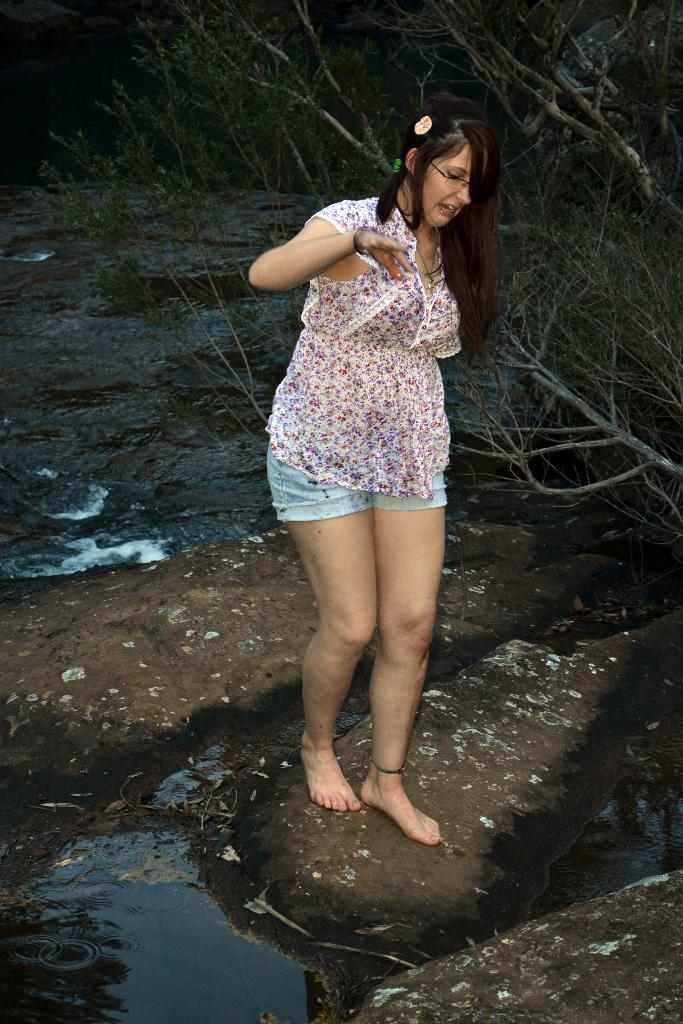What is at the bottom of the image? There is water at the bottom of the image. What can be seen on the right side of the image? There are trees on the right side of the image. What is the girl in the image doing? There is a girl walking in the middle of the image. How many sisters does the girl have in the image? There is no information about the girl's sisters in the image. What book is the girl reading while walking in the image? There is no book present in the image. 